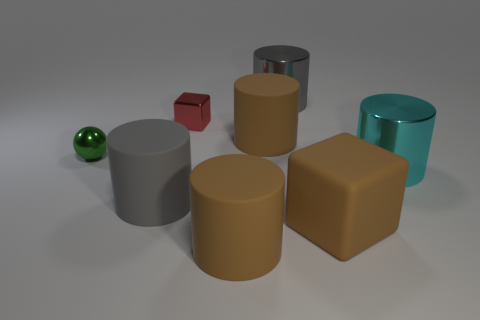Subtract all cyan cylinders. How many cylinders are left? 4 Subtract all cyan cylinders. How many cylinders are left? 4 Subtract all red cylinders. Subtract all yellow cubes. How many cylinders are left? 5 Add 2 big brown rubber cubes. How many objects exist? 10 Subtract all spheres. How many objects are left? 7 Add 5 small green objects. How many small green objects exist? 6 Subtract 0 blue cylinders. How many objects are left? 8 Subtract all matte cylinders. Subtract all cyan objects. How many objects are left? 4 Add 3 small green spheres. How many small green spheres are left? 4 